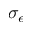<formula> <loc_0><loc_0><loc_500><loc_500>\sigma _ { \epsilon }</formula> 